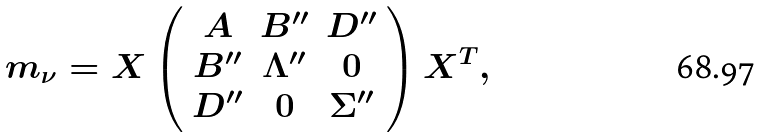Convert formula to latex. <formula><loc_0><loc_0><loc_500><loc_500>m _ { \nu } = X \left ( \begin{array} { c c c } A & B ^ { \prime \prime } & D ^ { \prime \prime } \\ B ^ { \prime \prime } & \Lambda ^ { \prime \prime } & 0 \\ D ^ { \prime \prime } & 0 & \Sigma ^ { \prime \prime } \\ \end{array} \right ) X ^ { T } ,</formula> 